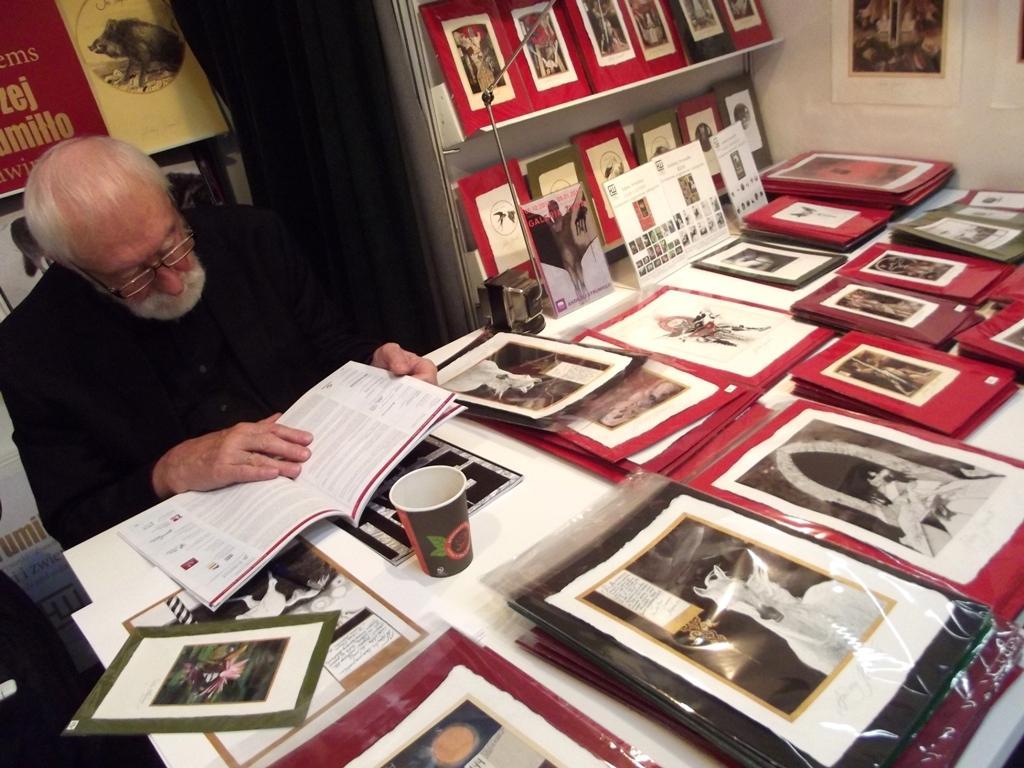Describe this image in one or two sentences. In this image, there is a white color table, on that table there are some papers kept in the covers, there is an old man sitting on the chair and he is reading a book, at the right side background there is a rack and there are some books in the rack. 